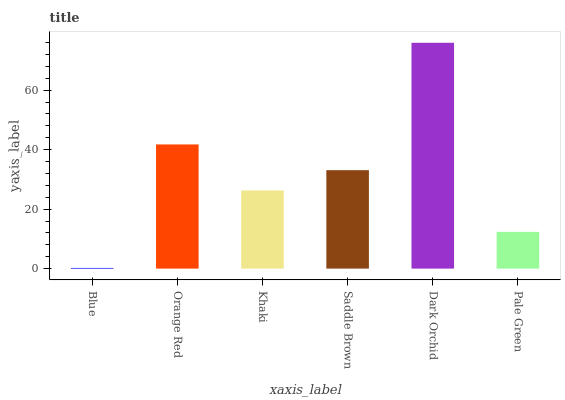Is Orange Red the minimum?
Answer yes or no. No. Is Orange Red the maximum?
Answer yes or no. No. Is Orange Red greater than Blue?
Answer yes or no. Yes. Is Blue less than Orange Red?
Answer yes or no. Yes. Is Blue greater than Orange Red?
Answer yes or no. No. Is Orange Red less than Blue?
Answer yes or no. No. Is Saddle Brown the high median?
Answer yes or no. Yes. Is Khaki the low median?
Answer yes or no. Yes. Is Pale Green the high median?
Answer yes or no. No. Is Pale Green the low median?
Answer yes or no. No. 